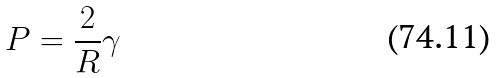<formula> <loc_0><loc_0><loc_500><loc_500>P = \frac { 2 } { R } \gamma</formula> 